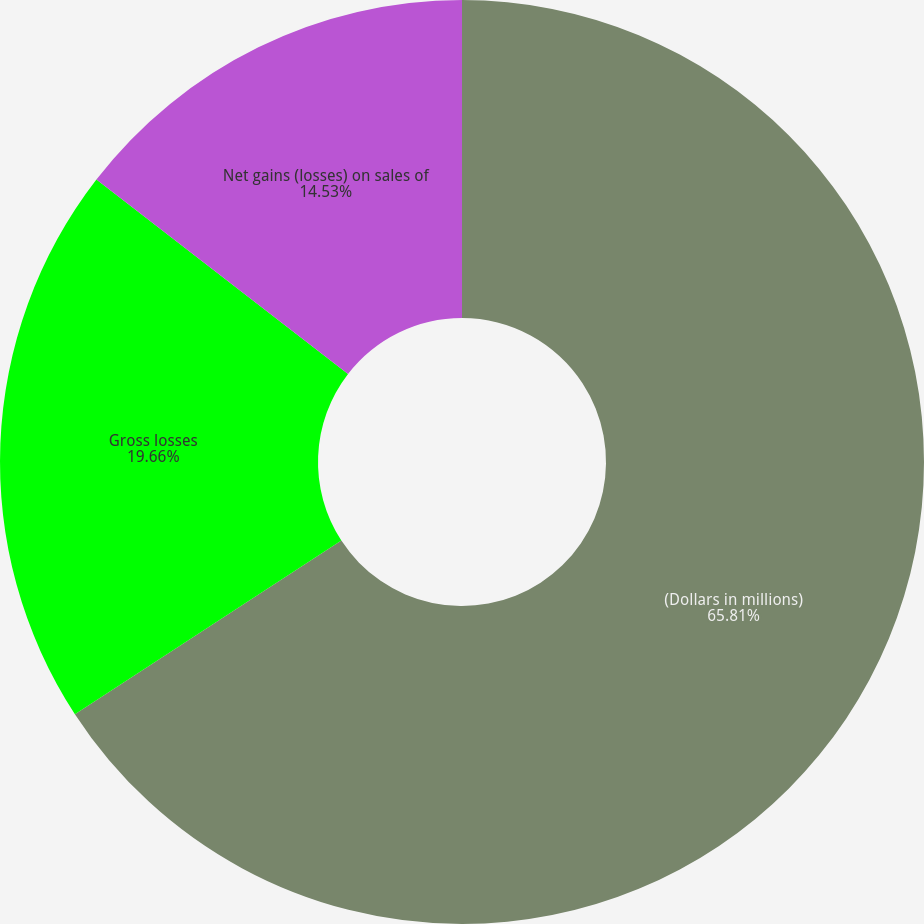Convert chart. <chart><loc_0><loc_0><loc_500><loc_500><pie_chart><fcel>(Dollars in millions)<fcel>Gross losses<fcel>Net gains (losses) on sales of<nl><fcel>65.81%<fcel>19.66%<fcel>14.53%<nl></chart> 